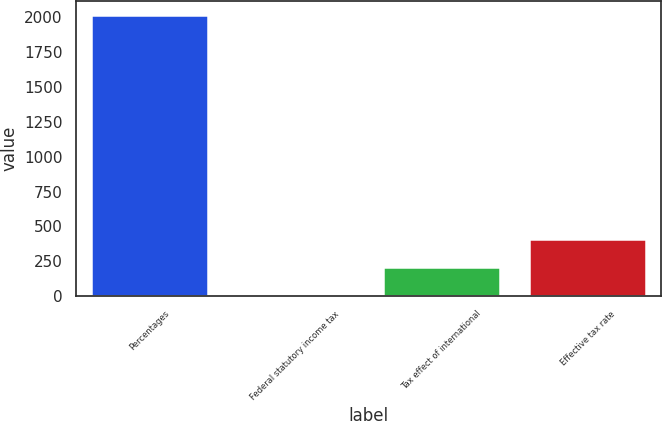Convert chart. <chart><loc_0><loc_0><loc_500><loc_500><bar_chart><fcel>Percentages<fcel>Federal statutory income tax<fcel>Tax effect of international<fcel>Effective tax rate<nl><fcel>2013<fcel>7.8<fcel>208.32<fcel>408.84<nl></chart> 